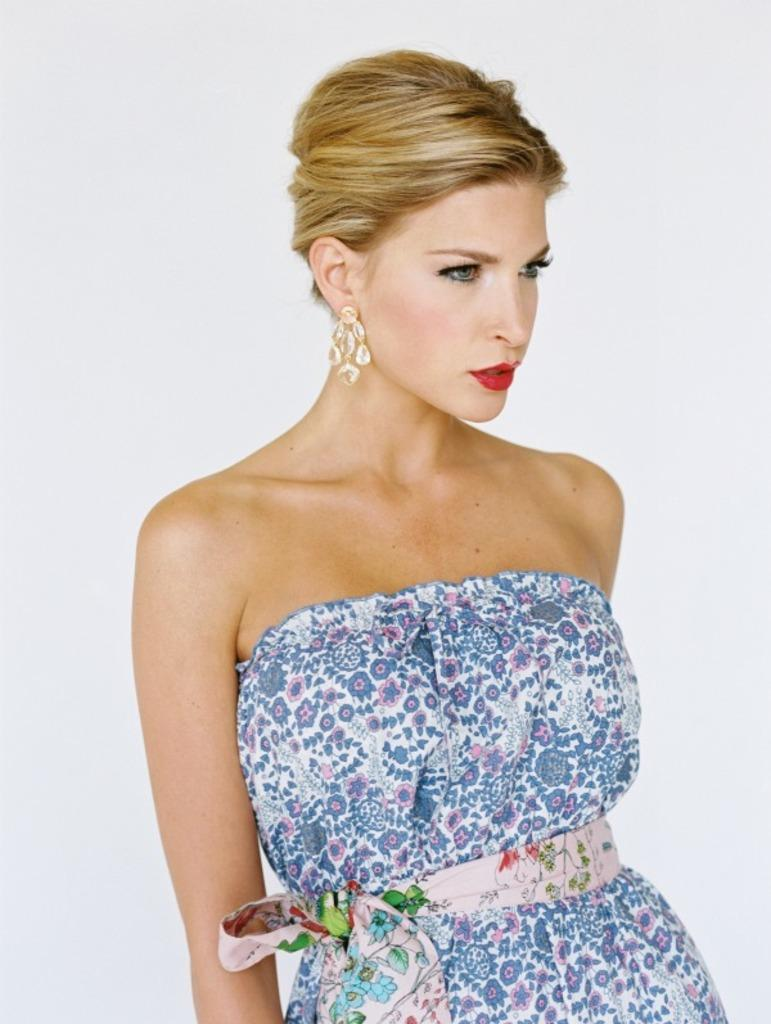What is the main subject of the image? There is a woman standing in the image. What is the woman wearing in the image? The woman is wearing a dress and earrings in the image. What can be observed about the background of the image? The background of the image appears to be white in color. What type of notebook is the man holding in the image? There is no man or notebook present in the image; it features a woman standing. What is the woman's interest in the image? The provided facts do not mention the woman's interests, so it cannot be determined from the image. 